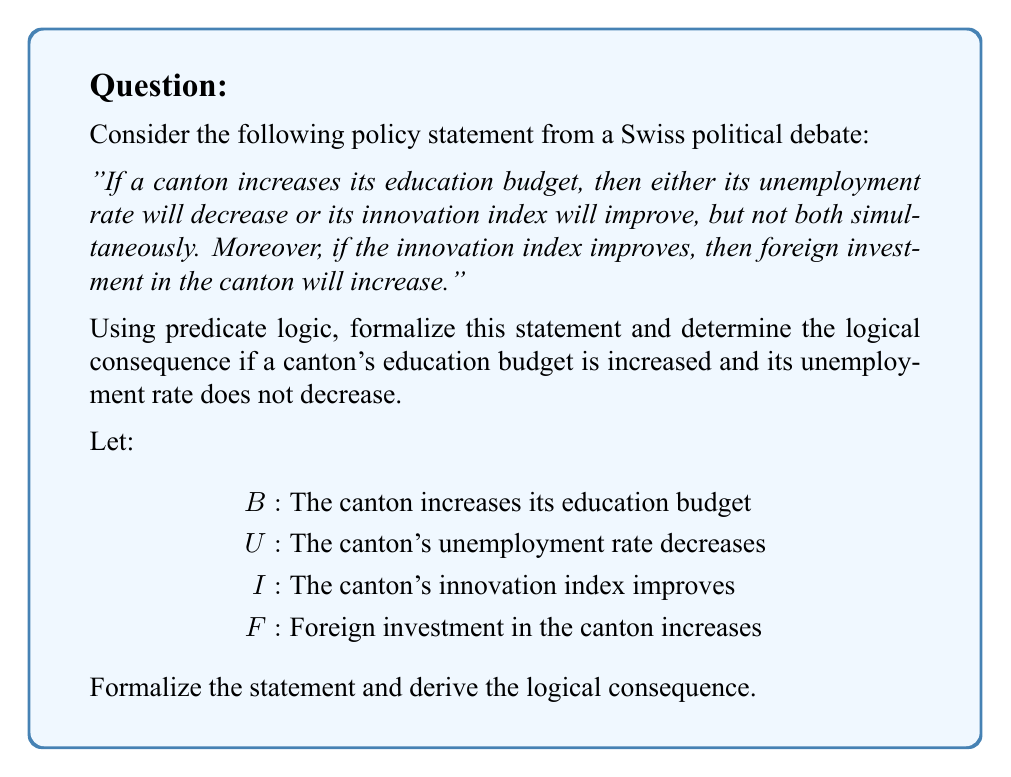Give your solution to this math problem. Step 1: Formalize the first part of the statement
The phrase "If a canton increases its education budget, then either its unemployment rate will decrease or its innovation index will improve, but not both simultaneously" can be formalized as:

$$B \rightarrow (U \oplus I)$$

Where $\oplus$ represents the exclusive OR (XOR) operation.

Step 2: Formalize the second part of the statement
"If the innovation index improves, then foreign investment in the canton will increase" can be formalized as:

$$I \rightarrow F$$

Step 3: Combine the two parts
The complete formalization of the policy statement is:

$$(B \rightarrow (U \oplus I)) \land (I \rightarrow F)$$

Step 4: Determine the logical consequence
Given:
- The canton increases its education budget: $B$ is true
- The unemployment rate does not decrease: $\lnot U$ is true

We can use modus ponens on the first part of the statement:
1. $B \rightarrow (U \oplus I)$ (from the formalization)
2. $B$ (given)
3. $U \oplus I$ (modus ponens from 1 and 2)

Since we know $\lnot U$ is true, and $U \oplus I$ is true, we can conclude that $I$ must be true (because XOR is true when exactly one of its operands is true).

Step 5: Use modus ponens again
Now that we know $I$ is true, we can use modus ponens on the second part of the statement:
1. $I \rightarrow F$ (from the formalization)
2. $I$ (derived in step 4)
3. $F$ (modus ponens from 1 and 2)

Therefore, the logical consequence is that foreign investment in the canton will increase ($F$).
Answer: $F$ (Foreign investment in the canton will increase) 